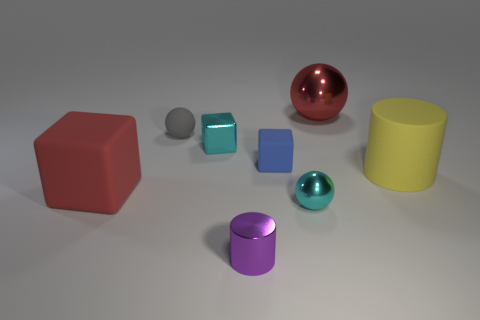Subtract all tiny cubes. How many cubes are left? 1 Subtract all cyan balls. How many balls are left? 2 Subtract all blocks. How many objects are left? 5 Add 1 big red things. How many objects exist? 9 Subtract 3 balls. How many balls are left? 0 Subtract all purple cylinders. Subtract all blue spheres. How many cylinders are left? 1 Subtract all blue cubes. How many cyan cylinders are left? 0 Subtract all tiny cyan rubber cylinders. Subtract all rubber cubes. How many objects are left? 6 Add 7 tiny metallic spheres. How many tiny metallic spheres are left? 8 Add 4 small cyan shiny cylinders. How many small cyan shiny cylinders exist? 4 